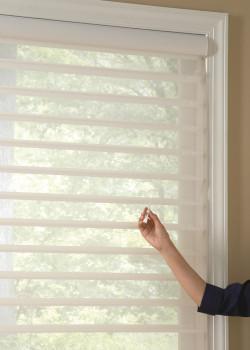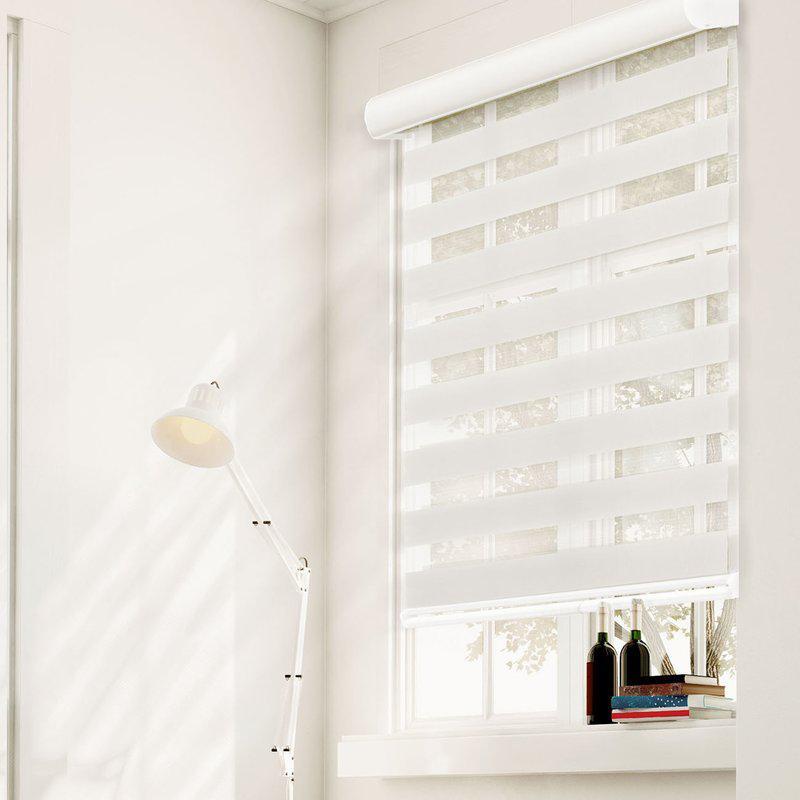The first image is the image on the left, the second image is the image on the right. Examine the images to the left and right. Is the description "There are no more than three blinds." accurate? Answer yes or no. Yes. 